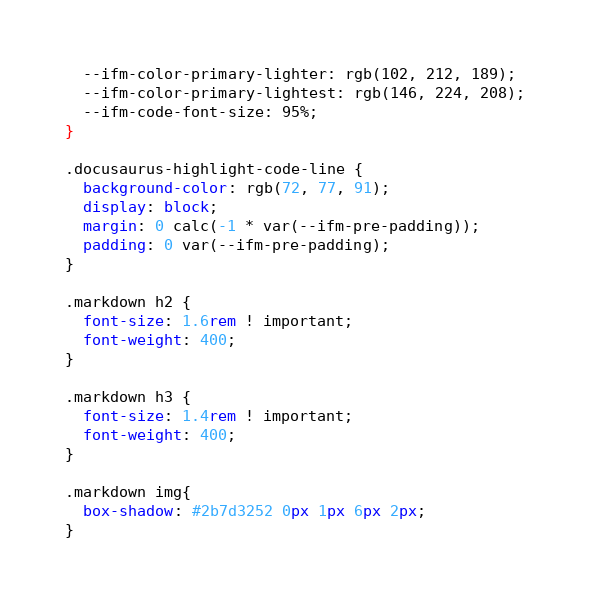Convert code to text. <code><loc_0><loc_0><loc_500><loc_500><_CSS_>  --ifm-color-primary-lighter: rgb(102, 212, 189);
  --ifm-color-primary-lightest: rgb(146, 224, 208);
  --ifm-code-font-size: 95%;
}

.docusaurus-highlight-code-line {
  background-color: rgb(72, 77, 91);
  display: block;
  margin: 0 calc(-1 * var(--ifm-pre-padding));
  padding: 0 var(--ifm-pre-padding);
}

.markdown h2 {
  font-size: 1.6rem ! important;
  font-weight: 400;
}

.markdown h3 {
  font-size: 1.4rem ! important;
  font-weight: 400;
}

.markdown img{
  box-shadow: #2b7d3252 0px 1px 6px 2px;
}

</code> 